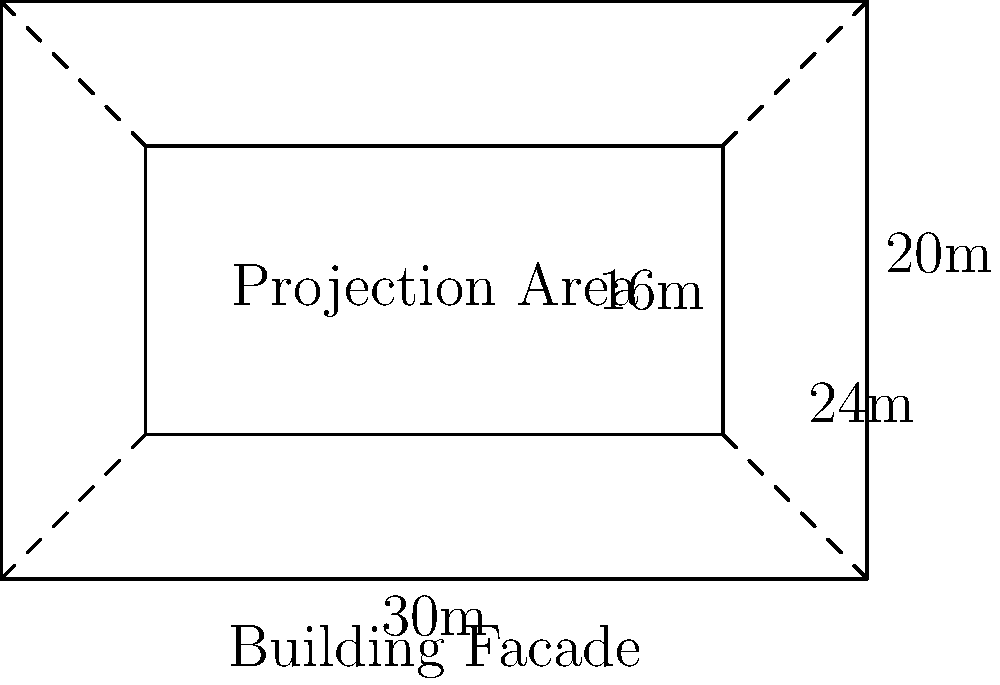You're planning a light-based guerrilla art installation on a building facade. The facade measures 30m wide and 20m high. Your projection equipment allows you to cover a rectangular area that's 80% of the facade's width and height. What is the area of your light projection in square meters? To solve this problem, let's follow these steps:

1. Calculate the dimensions of the projection area:
   - Width of projection = 80% of facade width
   - Width of projection = $0.80 \times 30\text{m} = 24\text{m}$
   - Height of projection = 80% of facade height
   - Height of projection = $0.80 \times 20\text{m} = 16\text{m}$

2. Calculate the area of the projection:
   - Area = width $\times$ height
   - Area = $24\text{m} \times 16\text{m} = 384\text{m}^2$

Therefore, the area of your light projection is 384 square meters.
Answer: $384\text{m}^2$ 